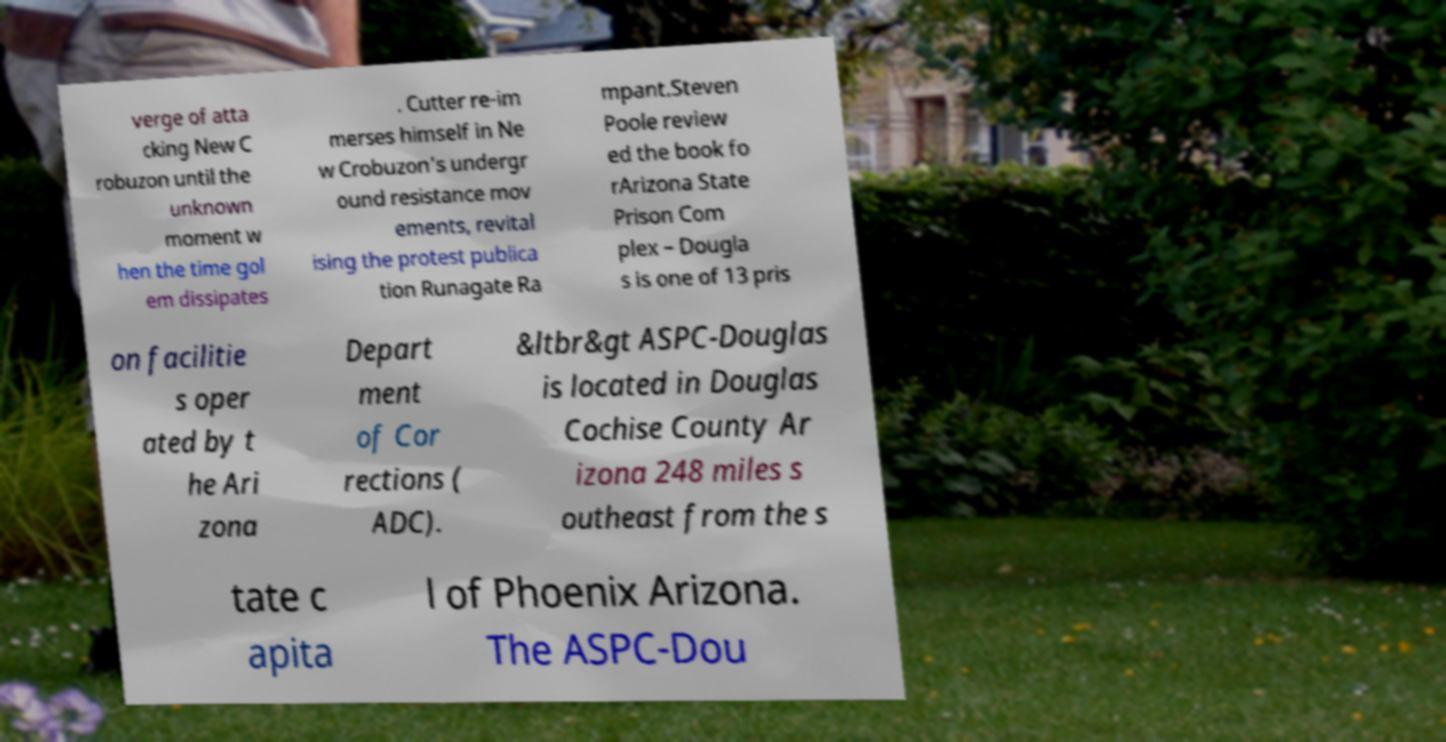What messages or text are displayed in this image? I need them in a readable, typed format. verge of atta cking New C robuzon until the unknown moment w hen the time gol em dissipates . Cutter re-im merses himself in Ne w Crobuzon's undergr ound resistance mov ements, revital ising the protest publica tion Runagate Ra mpant.Steven Poole review ed the book fo rArizona State Prison Com plex – Dougla s is one of 13 pris on facilitie s oper ated by t he Ari zona Depart ment of Cor rections ( ADC). &ltbr&gt ASPC-Douglas is located in Douglas Cochise County Ar izona 248 miles s outheast from the s tate c apita l of Phoenix Arizona. The ASPC-Dou 